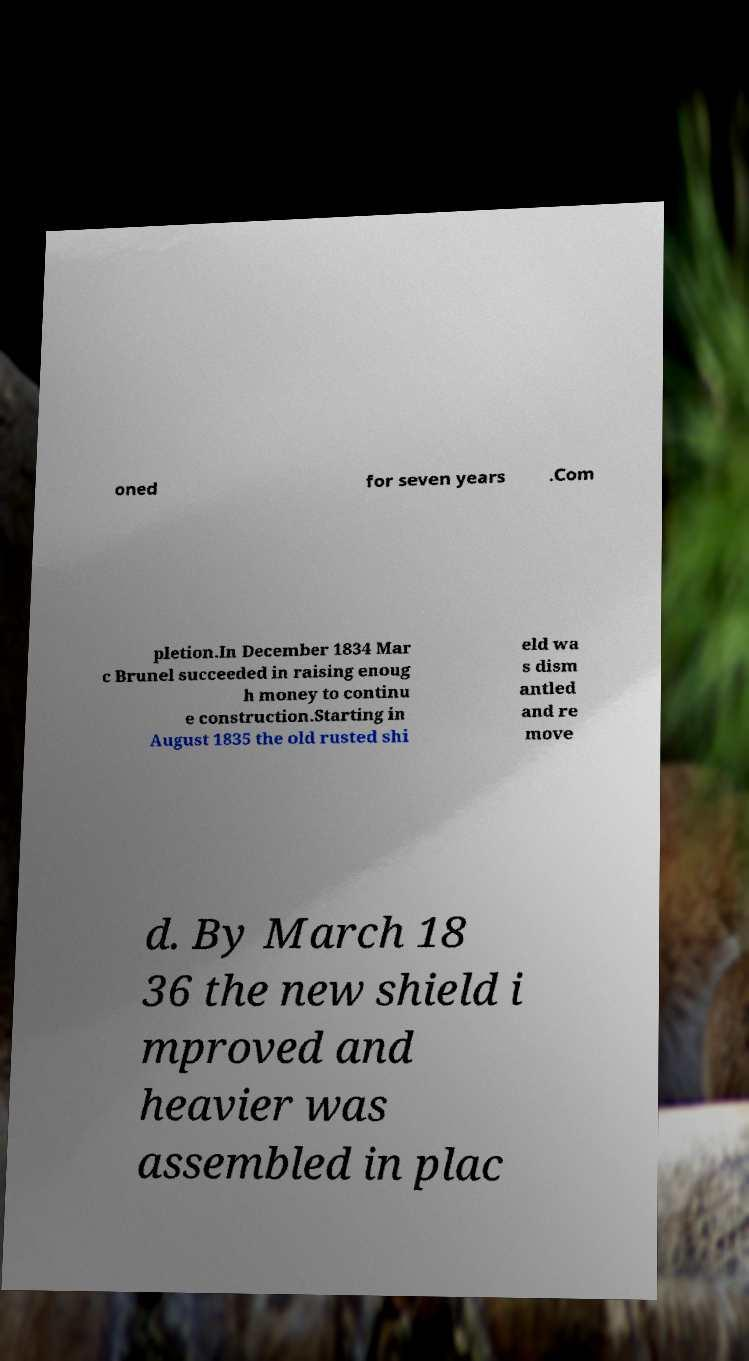Could you extract and type out the text from this image? oned for seven years .Com pletion.In December 1834 Mar c Brunel succeeded in raising enoug h money to continu e construction.Starting in August 1835 the old rusted shi eld wa s dism antled and re move d. By March 18 36 the new shield i mproved and heavier was assembled in plac 